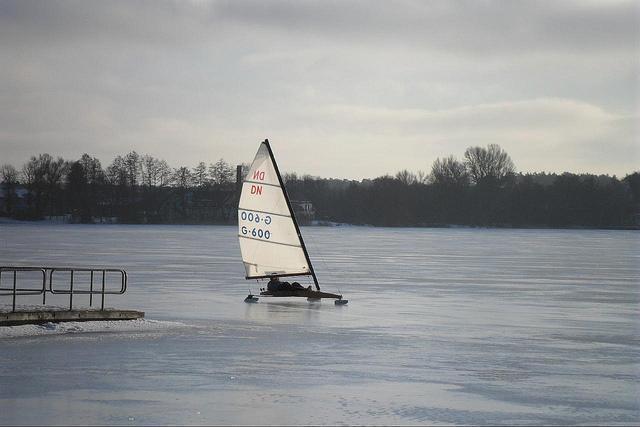In which manner does this vehicle move?
Select the accurate answer and provide explanation: 'Answer: answer
Rationale: rationale.'
Options: Flying, drilling, rolling, sliding. Answer: sliding.
Rationale: A boat is shown in the water. boats slide across the water as they move. 